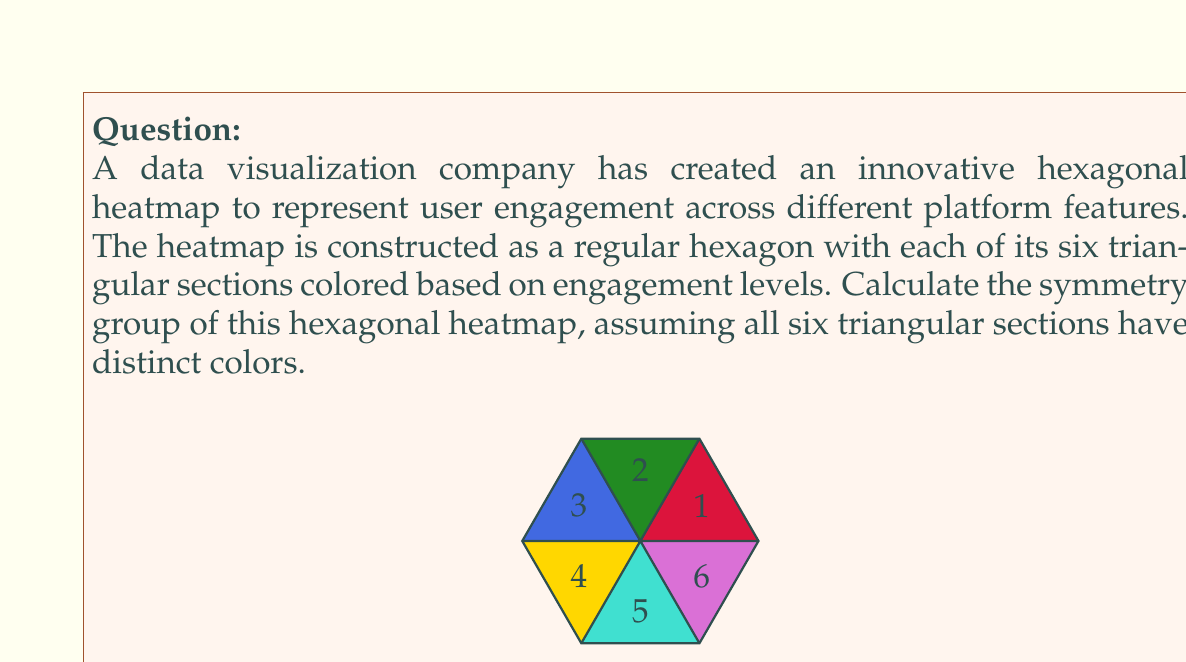Show me your answer to this math problem. To determine the symmetry group of the hexagonal heatmap, we need to consider all the transformations that leave the hexagon invariant while preserving the distinct colors of its sections. Let's approach this step-by-step:

1) First, let's consider rotational symmetries:
   - The hexagon has 6-fold rotational symmetry, but since all sections have distinct colors, only the identity rotation (360°) preserves the color arrangement.

2) Next, let's consider reflectional symmetries:
   - A regular hexagon typically has 6 lines of reflection (3 through opposite vertices and 3 through midpoints of opposite sides).
   - However, due to the distinct colors of each section, there are no reflections that preserve the color arrangement.

3) The only transformation that preserves both the shape and the color arrangement is the identity transformation.

4) In group theory, a group with only the identity element is called the trivial group.

5) The order of this group is 1, as it contains only one element (the identity).

6) In mathematical notation, this group is often denoted as $\{e\}$ or $C_1$ (cyclic group of order 1).

Therefore, the symmetry group of this hexagonal heatmap is the trivial group of order 1.
Answer: $C_1$ (trivial group) 